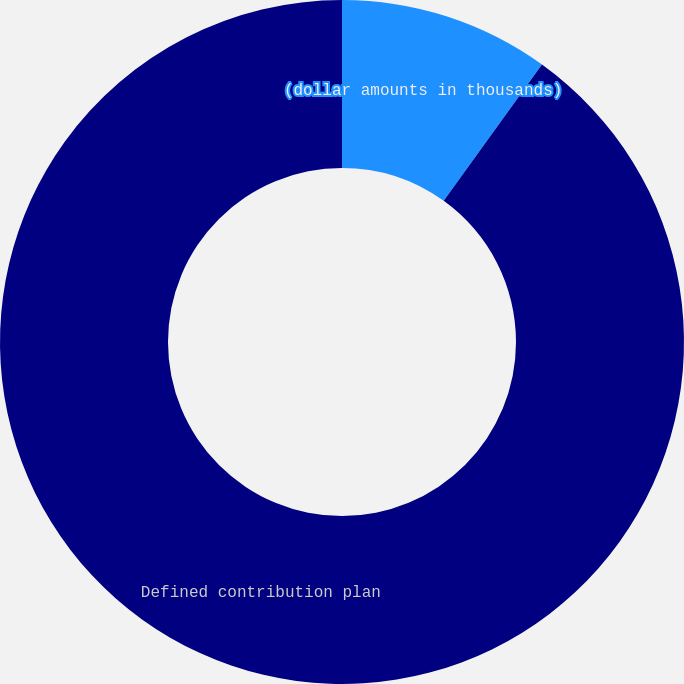<chart> <loc_0><loc_0><loc_500><loc_500><pie_chart><fcel>(dollar amounts in thousands)<fcel>Defined contribution plan<nl><fcel>9.94%<fcel>90.06%<nl></chart> 